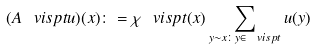<formula> <loc_0><loc_0><loc_500><loc_500>( A _ { \ } v i s p t u ) ( x ) \colon = \chi _ { \ } v i s p t ( x ) \sum _ { y \sim x \colon y \in \ v i s p t } u ( y )</formula> 